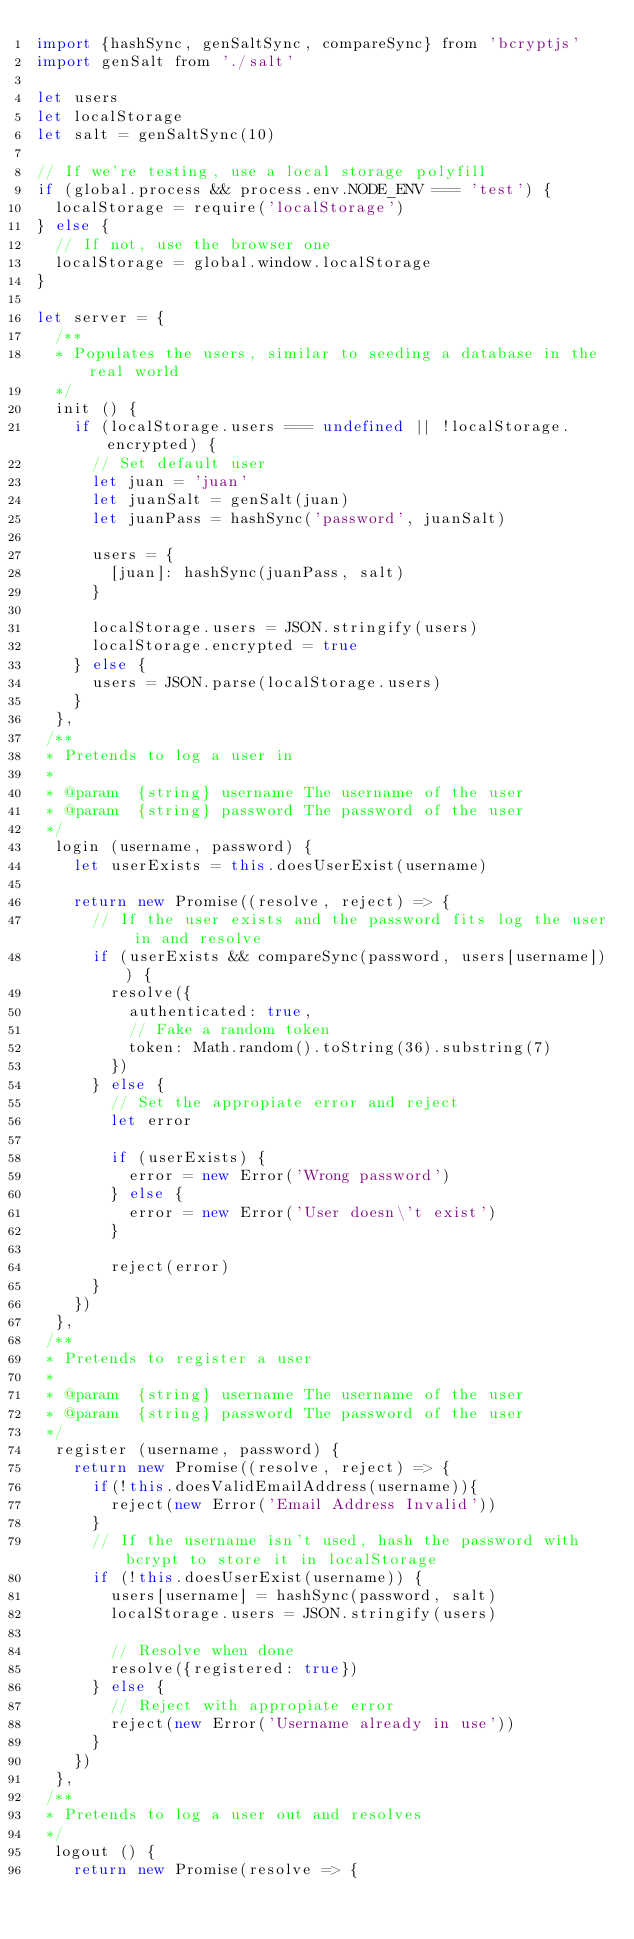<code> <loc_0><loc_0><loc_500><loc_500><_JavaScript_>import {hashSync, genSaltSync, compareSync} from 'bcryptjs'
import genSalt from './salt'

let users
let localStorage
let salt = genSaltSync(10)

// If we're testing, use a local storage polyfill
if (global.process && process.env.NODE_ENV === 'test') {
  localStorage = require('localStorage')
} else {
  // If not, use the browser one
  localStorage = global.window.localStorage
}

let server = {
  /**
  * Populates the users, similar to seeding a database in the real world
  */
  init () {
    if (localStorage.users === undefined || !localStorage.encrypted) {
      // Set default user
      let juan = 'juan'
      let juanSalt = genSalt(juan)
      let juanPass = hashSync('password', juanSalt)

      users = {
        [juan]: hashSync(juanPass, salt)
      }

      localStorage.users = JSON.stringify(users)
      localStorage.encrypted = true
    } else {
      users = JSON.parse(localStorage.users)
    }
  },
 /**
 * Pretends to log a user in
 *
 * @param  {string} username The username of the user
 * @param  {string} password The password of the user
 */
  login (username, password) {
    let userExists = this.doesUserExist(username)

    return new Promise((resolve, reject) => {
      // If the user exists and the password fits log the user in and resolve
      if (userExists && compareSync(password, users[username])) {
        resolve({
          authenticated: true,
          // Fake a random token
          token: Math.random().toString(36).substring(7)
        })
      } else {
        // Set the appropiate error and reject
        let error

        if (userExists) {
          error = new Error('Wrong password')
        } else {
          error = new Error('User doesn\'t exist')
        }

        reject(error)
      }
    })
  },
 /**
 * Pretends to register a user
 *
 * @param  {string} username The username of the user
 * @param  {string} password The password of the user
 */
  register (username, password) {
    return new Promise((resolve, reject) => {
		  if(!this.doesValidEmailAddress(username)){
        reject(new Error('Email Address Invalid'))
      }
      // If the username isn't used, hash the password with bcrypt to store it in localStorage
      if (!this.doesUserExist(username)) {
        users[username] = hashSync(password, salt)
        localStorage.users = JSON.stringify(users)

        // Resolve when done
        resolve({registered: true})
      } else {
        // Reject with appropiate error
        reject(new Error('Username already in use'))
      }
    })
  },
 /**
 * Pretends to log a user out and resolves
 */
  logout () {
    return new Promise(resolve => {</code> 